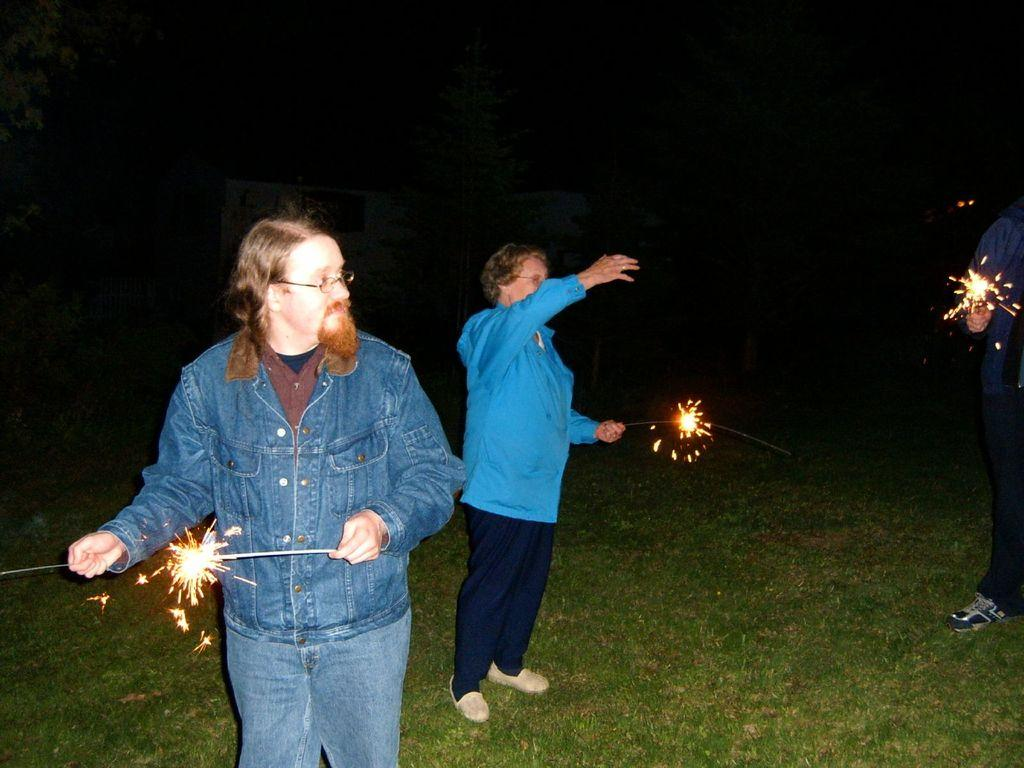How many people are in the image? There are three people in the image. What are the people doing in the image? The people are standing and holding sparkle sticks. What type of surface is visible beneath the people's feet? There is grass visible in the image. What can be seen in the background of the image? There are trees in the background of the image. What type of ring can be seen on the person's finger in the image? There is no ring visible on any person's finger in the image. What type of engine is powering the sparkle sticks in the image? The sparkle sticks in the image are not powered by an engine; they are likely held by the people for decorative purposes. 